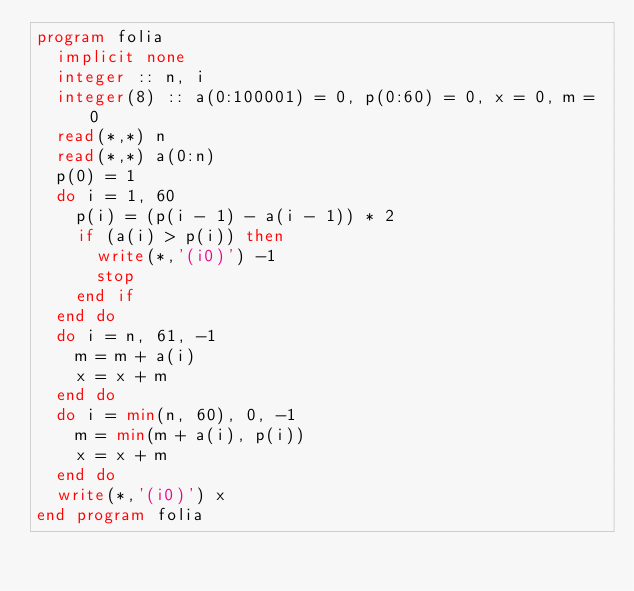Convert code to text. <code><loc_0><loc_0><loc_500><loc_500><_FORTRAN_>program folia
  implicit none
  integer :: n, i
  integer(8) :: a(0:100001) = 0, p(0:60) = 0, x = 0, m = 0
  read(*,*) n
  read(*,*) a(0:n)
  p(0) = 1
  do i = 1, 60
    p(i) = (p(i - 1) - a(i - 1)) * 2
    if (a(i) > p(i)) then
      write(*,'(i0)') -1
      stop
    end if
  end do
  do i = n, 61, -1
    m = m + a(i)
    x = x + m
  end do
  do i = min(n, 60), 0, -1
    m = min(m + a(i), p(i))
    x = x + m
  end do
  write(*,'(i0)') x
end program folia</code> 